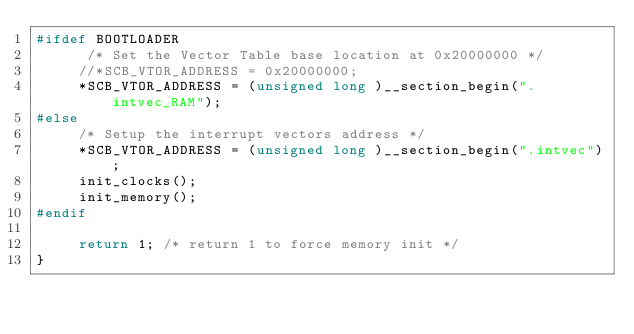<code> <loc_0><loc_0><loc_500><loc_500><_C_>#ifdef BOOTLOADER
      /* Set the Vector Table base location at 0x20000000 */
     //*SCB_VTOR_ADDRESS = 0x20000000;
     *SCB_VTOR_ADDRESS = (unsigned long )__section_begin(".intvec_RAM");
#else
     /* Setup the interrupt vectors address */
     *SCB_VTOR_ADDRESS = (unsigned long )__section_begin(".intvec");
     init_clocks();
     init_memory();
#endif

     return 1; /* return 1 to force memory init */
}
</code> 